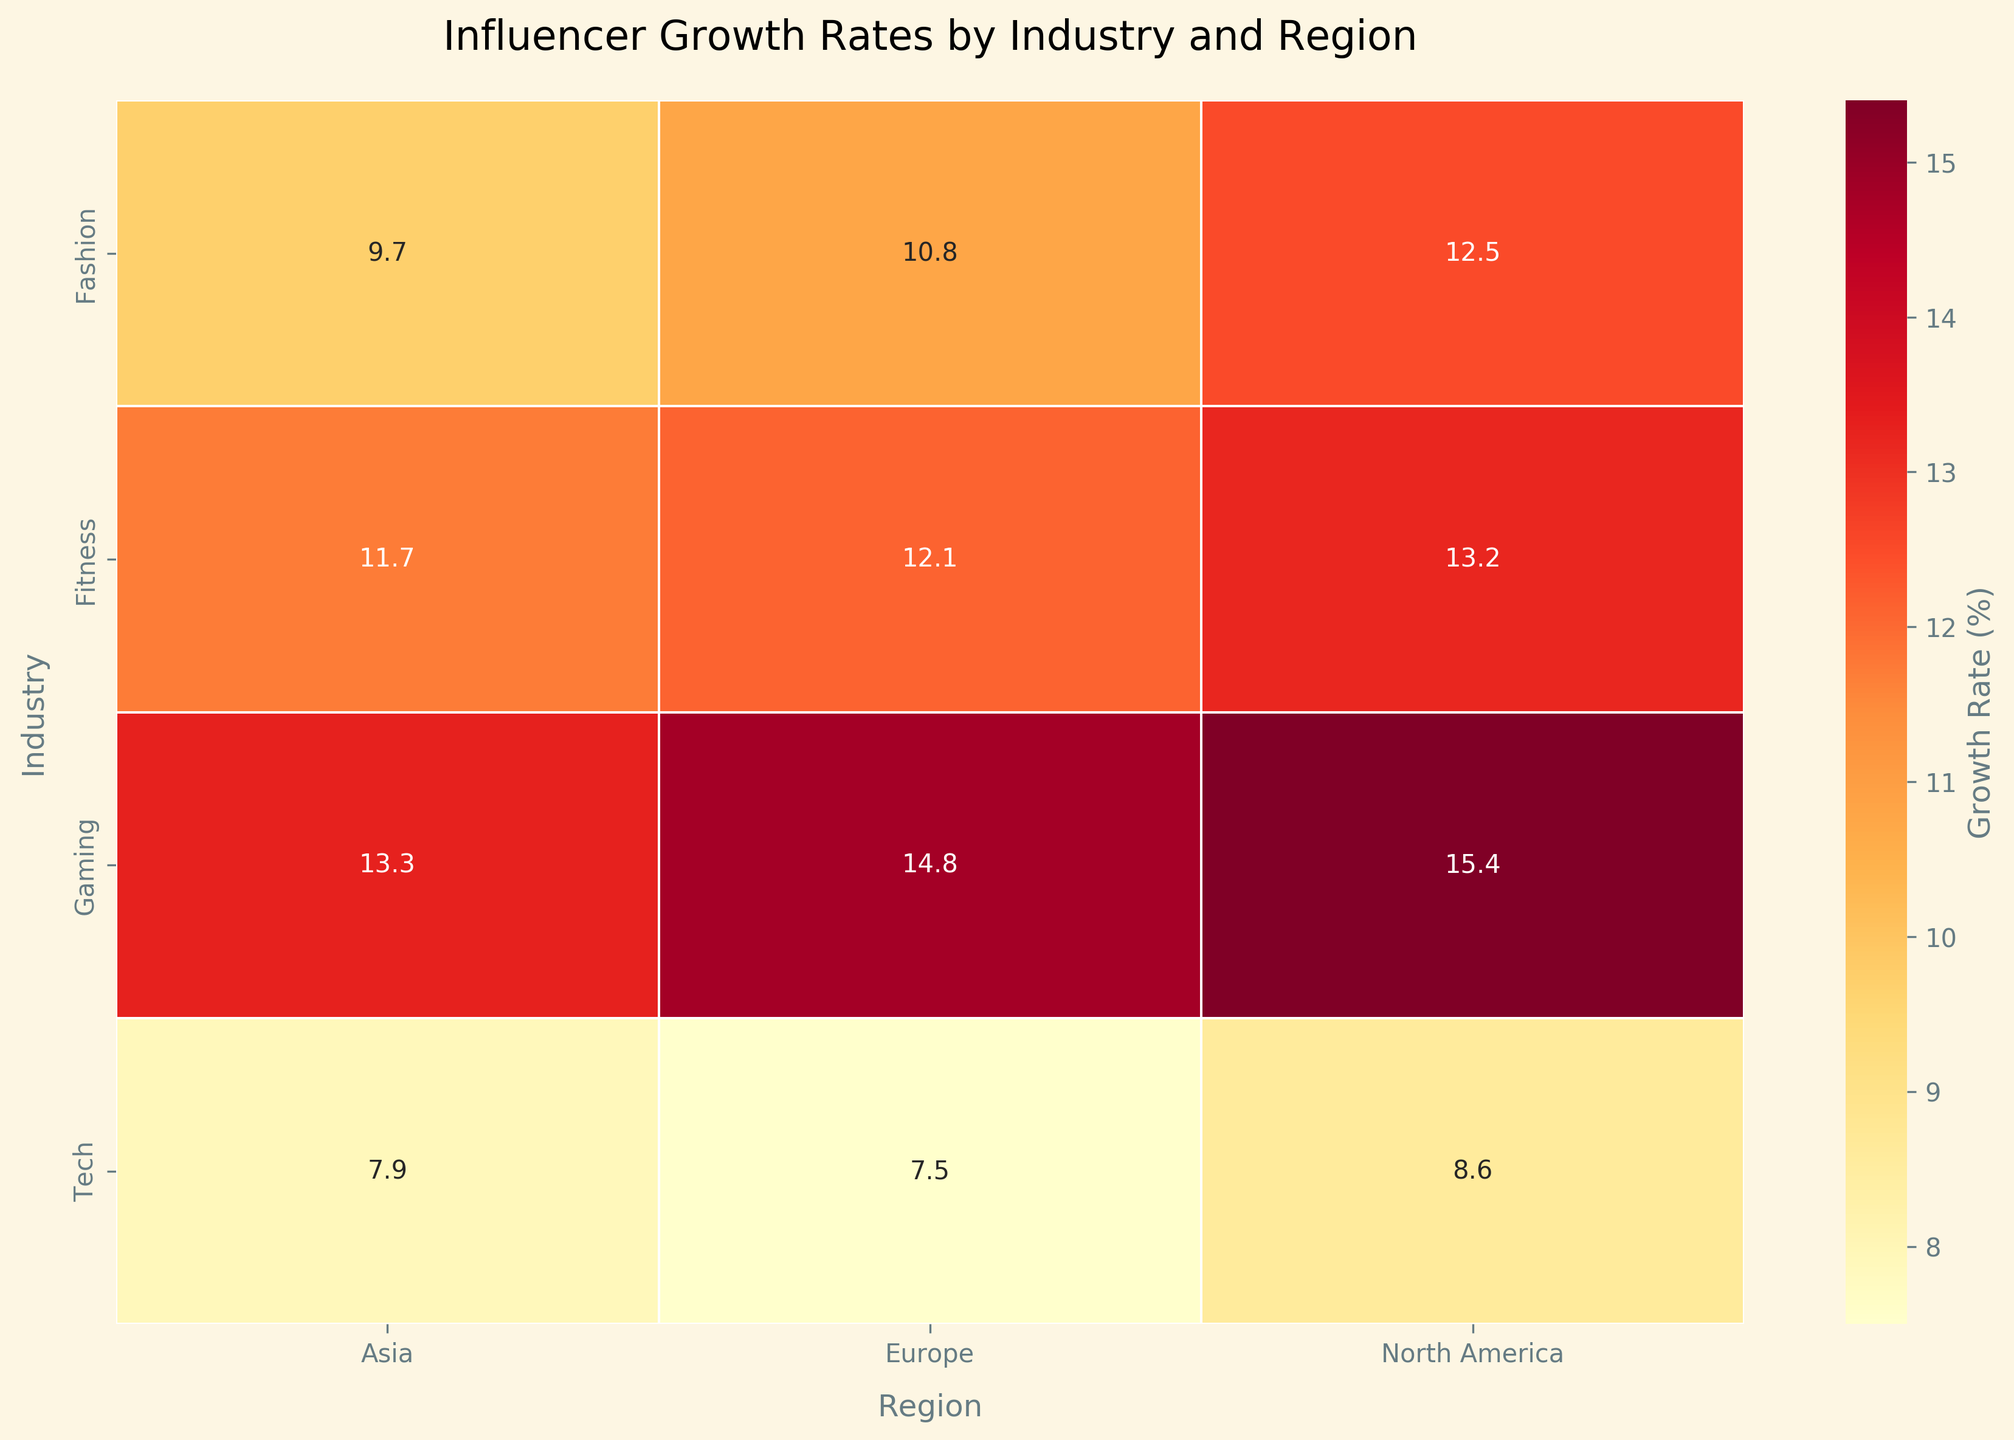What's the title of the heatmap? The title of the heatmap is usually found at the top of the chart and summarizes the content being displayed. Here it's indicated in the `plt.title()` call in the code.
Answer: Influencer Growth Rates by Industry and Region What are the axes labels on the heatmap? The axes labels are indicated by the `plt.xlabel()` and `plt.ylabel()` functions in the code and specify which dimensions are being plotted. In the heatmap, the horizontal axis has the label 'Region,' and the vertical axis has the label 'Industry.'
Answer: Region, Industry Which region has the highest growth rate in the Gaming industry? By examining the heatmap in the 'Gaming' row, we can compare the values for each region. The highest growth rate is evident by the darkest color shade. North America: 15.4, Europe: 14.8, Asia: 13.3.
Answer: North America What is the average growth rate for the Fashion industry across all regions? Locate the 'Fashion' row and sum up the growth rates for North America, Europe, and Asia: (12.5 + 10.8 + 9.7)/3 = 33.0/3
Answer: 11.0 Which industry in North America has the lowest growth rate? Examine the 'North America' column and identify the industry with the lightest shade (lowest value). By comparing, we find: Fashion: 12.5, Tech: 8.6, Fitness: 13.2, Gaming: 15.4. The lowest value corresponds to the Tech industry.
Answer: Tech Compare the Instagram growth rates in the Fitness industry across different regions. Which region has the highest growth rate? Look at the 'Fitness' row and 'Instagram' platform data for North America, Europe, and Asia. North America: 13.2, Europe: 12.1, Asia: 11.7. The highest value is in North America.
Answer: North America How do the growth rates in the Tech industry compare between North America and Europe? Check the 'Tech' row for North America and Europe columns. North America: 8.6, Europe: 7.5. Compare these values.
Answer: North America is higher What's the difference in growth rates between the highest and lowest industries in Asia? Identify the values in the Asia column: Fashion: 9.7, Tech: 7.9, Fitness: 11.7, Gaming: 13.3. The highest is Gaming (13.3) and the lowest is Tech (7.9). Difference: 13.3 - 7.9 = 5.4.
Answer: 5.4 Which industry has the most uniform growth rate across all regions? Look for the row with the smallest variation between regions. Comparing the values, it's evident that 'Tech' is relatively more uniform: North America: 8.6, Europe: 7.5, Asia: 7.9.
Answer: Tech 